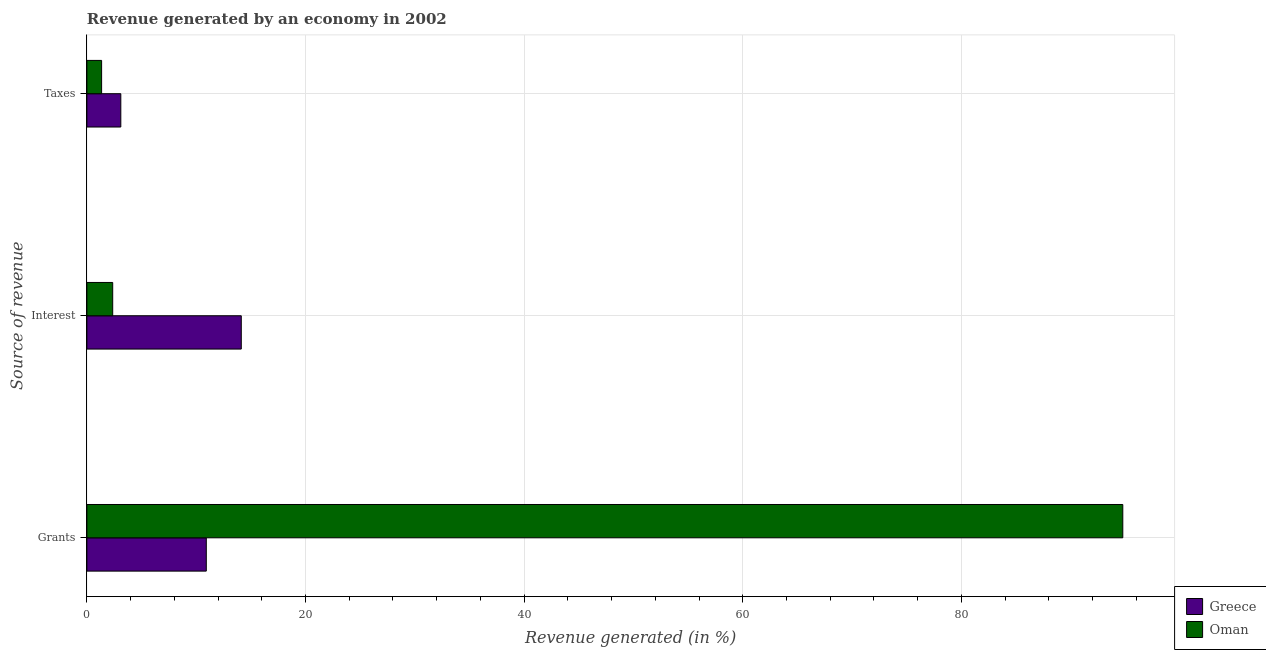Are the number of bars per tick equal to the number of legend labels?
Keep it short and to the point. Yes. What is the label of the 3rd group of bars from the top?
Keep it short and to the point. Grants. What is the percentage of revenue generated by taxes in Oman?
Your answer should be very brief. 1.35. Across all countries, what is the maximum percentage of revenue generated by grants?
Your answer should be compact. 94.76. Across all countries, what is the minimum percentage of revenue generated by grants?
Offer a very short reply. 10.92. In which country was the percentage of revenue generated by grants maximum?
Keep it short and to the point. Oman. In which country was the percentage of revenue generated by taxes minimum?
Provide a succinct answer. Oman. What is the total percentage of revenue generated by taxes in the graph?
Offer a terse response. 4.45. What is the difference between the percentage of revenue generated by taxes in Greece and that in Oman?
Your answer should be very brief. 1.76. What is the difference between the percentage of revenue generated by taxes in Oman and the percentage of revenue generated by interest in Greece?
Give a very brief answer. -12.78. What is the average percentage of revenue generated by grants per country?
Your answer should be compact. 52.84. What is the difference between the percentage of revenue generated by taxes and percentage of revenue generated by grants in Greece?
Ensure brevity in your answer.  -7.82. What is the ratio of the percentage of revenue generated by interest in Oman to that in Greece?
Your answer should be very brief. 0.17. What is the difference between the highest and the second highest percentage of revenue generated by grants?
Provide a succinct answer. 83.84. What is the difference between the highest and the lowest percentage of revenue generated by grants?
Your answer should be very brief. 83.84. In how many countries, is the percentage of revenue generated by grants greater than the average percentage of revenue generated by grants taken over all countries?
Give a very brief answer. 1. Is the sum of the percentage of revenue generated by taxes in Oman and Greece greater than the maximum percentage of revenue generated by grants across all countries?
Offer a terse response. No. What does the 2nd bar from the top in Taxes represents?
Offer a very short reply. Greece. How many countries are there in the graph?
Your answer should be compact. 2. Are the values on the major ticks of X-axis written in scientific E-notation?
Your answer should be compact. No. Does the graph contain any zero values?
Keep it short and to the point. No. Does the graph contain grids?
Provide a short and direct response. Yes. Where does the legend appear in the graph?
Give a very brief answer. Bottom right. How are the legend labels stacked?
Provide a short and direct response. Vertical. What is the title of the graph?
Your response must be concise. Revenue generated by an economy in 2002. Does "Singapore" appear as one of the legend labels in the graph?
Provide a short and direct response. No. What is the label or title of the X-axis?
Make the answer very short. Revenue generated (in %). What is the label or title of the Y-axis?
Keep it short and to the point. Source of revenue. What is the Revenue generated (in %) of Greece in Grants?
Make the answer very short. 10.92. What is the Revenue generated (in %) in Oman in Grants?
Your answer should be very brief. 94.76. What is the Revenue generated (in %) of Greece in Interest?
Your answer should be compact. 14.12. What is the Revenue generated (in %) of Oman in Interest?
Your answer should be very brief. 2.36. What is the Revenue generated (in %) in Greece in Taxes?
Offer a very short reply. 3.1. What is the Revenue generated (in %) of Oman in Taxes?
Ensure brevity in your answer.  1.35. Across all Source of revenue, what is the maximum Revenue generated (in %) of Greece?
Offer a very short reply. 14.12. Across all Source of revenue, what is the maximum Revenue generated (in %) of Oman?
Your answer should be very brief. 94.76. Across all Source of revenue, what is the minimum Revenue generated (in %) in Greece?
Provide a succinct answer. 3.1. Across all Source of revenue, what is the minimum Revenue generated (in %) in Oman?
Offer a very short reply. 1.35. What is the total Revenue generated (in %) of Greece in the graph?
Give a very brief answer. 28.15. What is the total Revenue generated (in %) in Oman in the graph?
Provide a short and direct response. 98.47. What is the difference between the Revenue generated (in %) of Greece in Grants and that in Interest?
Keep it short and to the point. -3.2. What is the difference between the Revenue generated (in %) in Oman in Grants and that in Interest?
Offer a very short reply. 92.4. What is the difference between the Revenue generated (in %) in Greece in Grants and that in Taxes?
Give a very brief answer. 7.82. What is the difference between the Revenue generated (in %) of Oman in Grants and that in Taxes?
Offer a very short reply. 93.42. What is the difference between the Revenue generated (in %) of Greece in Interest and that in Taxes?
Give a very brief answer. 11.02. What is the difference between the Revenue generated (in %) of Oman in Interest and that in Taxes?
Your answer should be compact. 1.02. What is the difference between the Revenue generated (in %) of Greece in Grants and the Revenue generated (in %) of Oman in Interest?
Offer a terse response. 8.56. What is the difference between the Revenue generated (in %) of Greece in Grants and the Revenue generated (in %) of Oman in Taxes?
Provide a short and direct response. 9.58. What is the difference between the Revenue generated (in %) of Greece in Interest and the Revenue generated (in %) of Oman in Taxes?
Ensure brevity in your answer.  12.78. What is the average Revenue generated (in %) of Greece per Source of revenue?
Offer a terse response. 9.38. What is the average Revenue generated (in %) of Oman per Source of revenue?
Keep it short and to the point. 32.82. What is the difference between the Revenue generated (in %) of Greece and Revenue generated (in %) of Oman in Grants?
Your answer should be compact. -83.84. What is the difference between the Revenue generated (in %) in Greece and Revenue generated (in %) in Oman in Interest?
Provide a short and direct response. 11.76. What is the difference between the Revenue generated (in %) of Greece and Revenue generated (in %) of Oman in Taxes?
Provide a short and direct response. 1.76. What is the ratio of the Revenue generated (in %) in Greece in Grants to that in Interest?
Give a very brief answer. 0.77. What is the ratio of the Revenue generated (in %) in Oman in Grants to that in Interest?
Keep it short and to the point. 40.11. What is the ratio of the Revenue generated (in %) in Greece in Grants to that in Taxes?
Ensure brevity in your answer.  3.52. What is the ratio of the Revenue generated (in %) of Oman in Grants to that in Taxes?
Keep it short and to the point. 70.34. What is the ratio of the Revenue generated (in %) of Greece in Interest to that in Taxes?
Make the answer very short. 4.55. What is the ratio of the Revenue generated (in %) in Oman in Interest to that in Taxes?
Keep it short and to the point. 1.75. What is the difference between the highest and the second highest Revenue generated (in %) in Greece?
Keep it short and to the point. 3.2. What is the difference between the highest and the second highest Revenue generated (in %) of Oman?
Your response must be concise. 92.4. What is the difference between the highest and the lowest Revenue generated (in %) of Greece?
Give a very brief answer. 11.02. What is the difference between the highest and the lowest Revenue generated (in %) of Oman?
Keep it short and to the point. 93.42. 